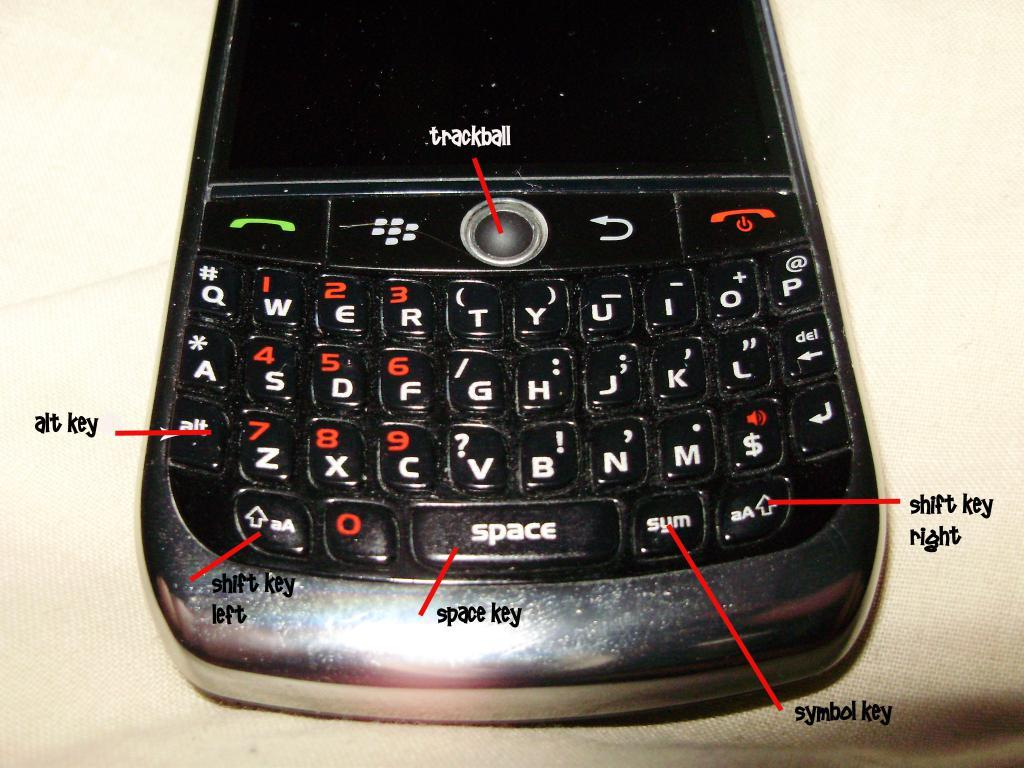<image>
Provide a brief description of the given image. a close up of an old Blackberry key pad with signs to Trackball and Symbol Key 